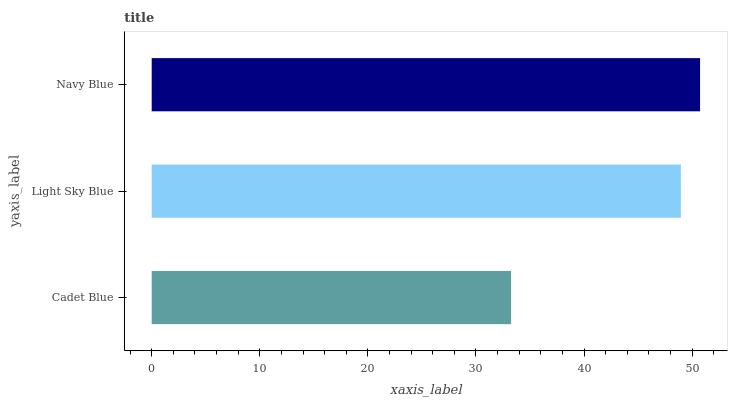Is Cadet Blue the minimum?
Answer yes or no. Yes. Is Navy Blue the maximum?
Answer yes or no. Yes. Is Light Sky Blue the minimum?
Answer yes or no. No. Is Light Sky Blue the maximum?
Answer yes or no. No. Is Light Sky Blue greater than Cadet Blue?
Answer yes or no. Yes. Is Cadet Blue less than Light Sky Blue?
Answer yes or no. Yes. Is Cadet Blue greater than Light Sky Blue?
Answer yes or no. No. Is Light Sky Blue less than Cadet Blue?
Answer yes or no. No. Is Light Sky Blue the high median?
Answer yes or no. Yes. Is Light Sky Blue the low median?
Answer yes or no. Yes. Is Cadet Blue the high median?
Answer yes or no. No. Is Cadet Blue the low median?
Answer yes or no. No. 